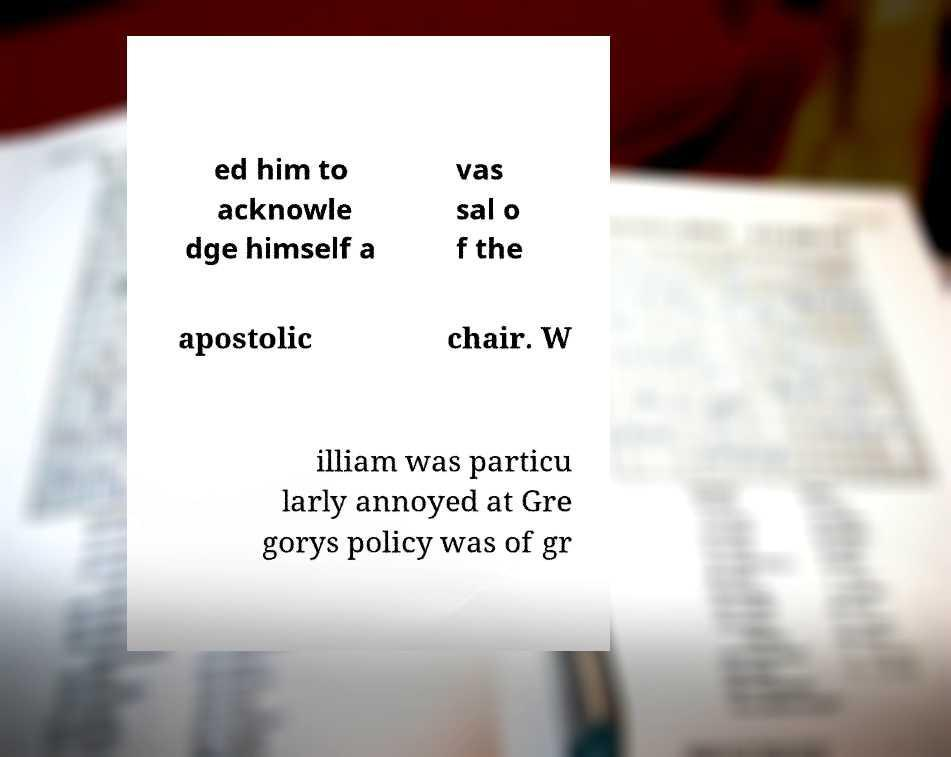Could you assist in decoding the text presented in this image and type it out clearly? ed him to acknowle dge himself a vas sal o f the apostolic chair. W illiam was particu larly annoyed at Gre gorys policy was of gr 